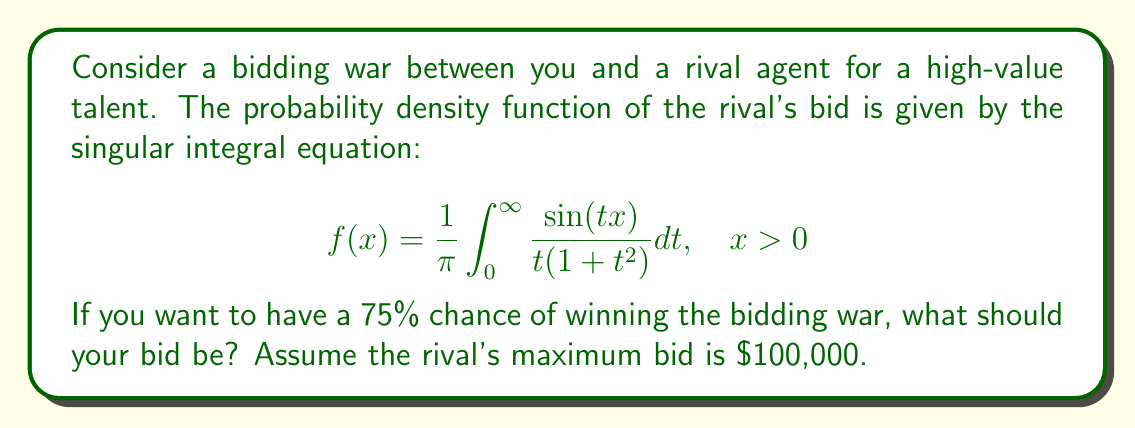Can you answer this question? To solve this problem, we need to follow these steps:

1) First, we recognize that the given integral is the probability density function (PDF) of the Cauchy distribution with location parameter 0 and scale parameter 1.

2) The cumulative distribution function (CDF) of the Cauchy distribution is:

   $$F(x) = \frac{1}{2} + \frac{1}{\pi} \arctan(x)$$

3) We want to find the value of x such that F(x) = 0.75, as this represents the 75th percentile of the distribution.

4) Let's set up the equation:

   $$0.75 = \frac{1}{2} + \frac{1}{\pi} \arctan(x)$$

5) Solve for x:

   $$0.25 = \frac{1}{\pi} \arctan(x)$$
   $$\pi(0.25) = \arctan(x)$$
   $$x = \tan(\pi/4) = 1$$

6) This result is in the standard Cauchy distribution. We need to scale it to the maximum bid of $100,000.

7) The scaled result is:

   $$100,000 \cdot 1 = 100,000$$

Therefore, to have a 75% chance of winning the bidding war, you should bid $100,000.
Answer: $100,000 